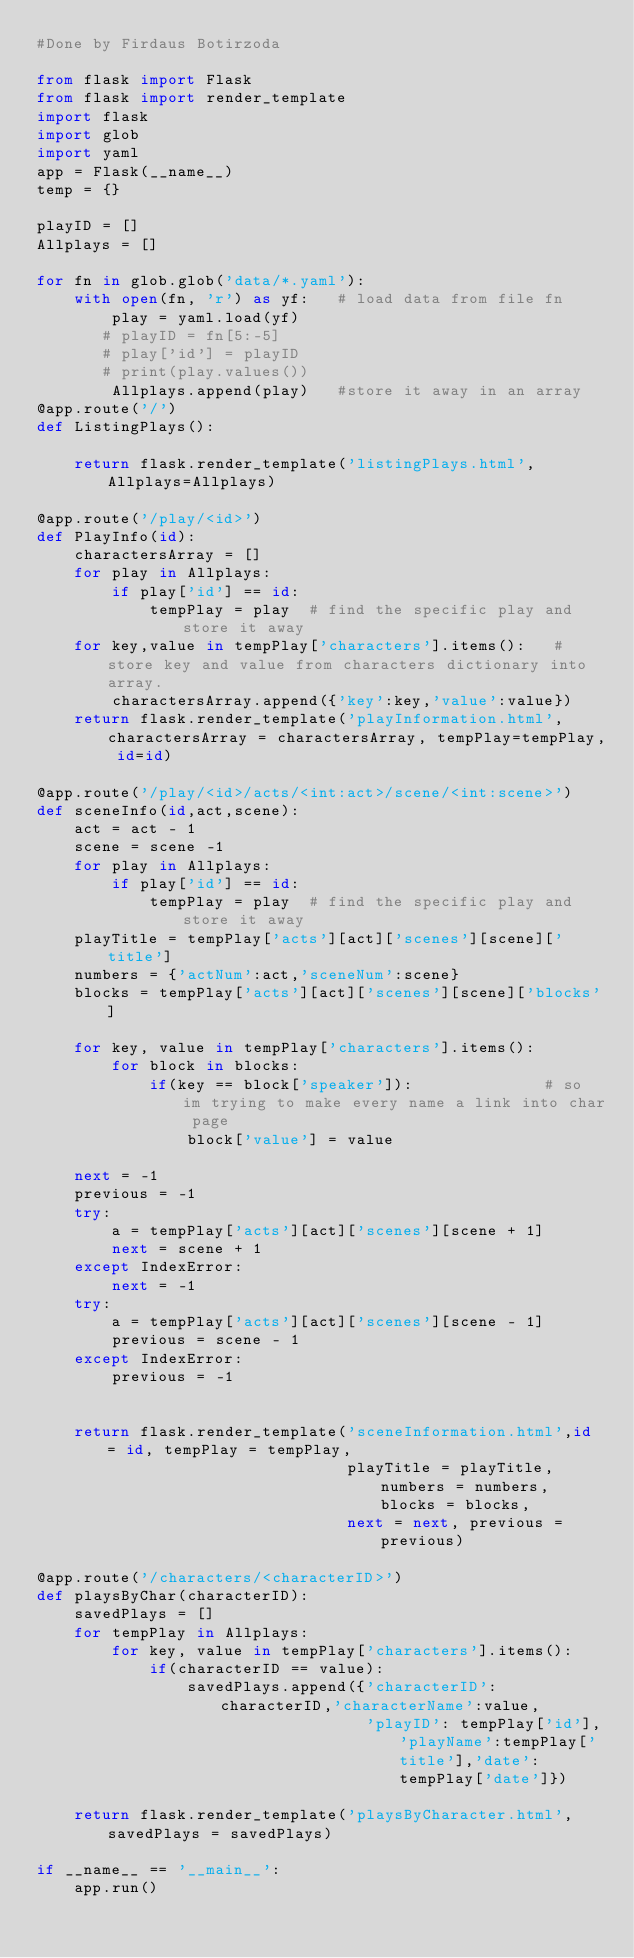Convert code to text. <code><loc_0><loc_0><loc_500><loc_500><_Python_>#Done by Firdaus Botirzoda

from flask import Flask
from flask import render_template
import flask
import glob
import yaml
app = Flask(__name__)
temp = {}

playID = []
Allplays = []

for fn in glob.glob('data/*.yaml'):
    with open(fn, 'r') as yf:   # load data from file fn
        play = yaml.load(yf)
       # playID = fn[5:-5]
       # play['id'] = playID
       # print(play.values())
        Allplays.append(play)   #store it away in an array
@app.route('/')
def ListingPlays():

    return flask.render_template('listingPlays.html', Allplays=Allplays)

@app.route('/play/<id>')
def PlayInfo(id):
    charactersArray = []
    for play in Allplays:
        if play['id'] == id:
            tempPlay = play  # find the specific play and store it away
    for key,value in tempPlay['characters'].items():   # store key and value from characters dictionary into array.
        charactersArray.append({'key':key,'value':value})
    return flask.render_template('playInformation.html',charactersArray = charactersArray, tempPlay=tempPlay, id=id)

@app.route('/play/<id>/acts/<int:act>/scene/<int:scene>')
def sceneInfo(id,act,scene):
    act = act - 1
    scene = scene -1
    for play in Allplays:
        if play['id'] == id:
            tempPlay = play  # find the specific play and store it away
    playTitle = tempPlay['acts'][act]['scenes'][scene]['title']
    numbers = {'actNum':act,'sceneNum':scene}
    blocks = tempPlay['acts'][act]['scenes'][scene]['blocks']

    for key, value in tempPlay['characters'].items():
        for block in blocks:
            if(key == block['speaker']):              # so im trying to make every name a link into char page
                block['value'] = value

    next = -1
    previous = -1
    try:
        a = tempPlay['acts'][act]['scenes'][scene + 1]
        next = scene + 1
    except IndexError:
        next = -1
    try:
        a = tempPlay['acts'][act]['scenes'][scene - 1]
        previous = scene - 1
    except IndexError:
        previous = -1


    return flask.render_template('sceneInformation.html',id = id, tempPlay = tempPlay,
                                 playTitle = playTitle,numbers = numbers, blocks = blocks,
                                 next = next, previous = previous)

@app.route('/characters/<characterID>')
def playsByChar(characterID):
    savedPlays = []
    for tempPlay in Allplays:
        for key, value in tempPlay['characters'].items():
            if(characterID == value):
                savedPlays.append({'characterID': characterID,'characterName':value,
                                   'playID': tempPlay['id'],'playName':tempPlay['title'],'date':tempPlay['date']})

    return flask.render_template('playsByCharacter.html', savedPlays = savedPlays)

if __name__ == '__main__':
    app.run()

</code> 